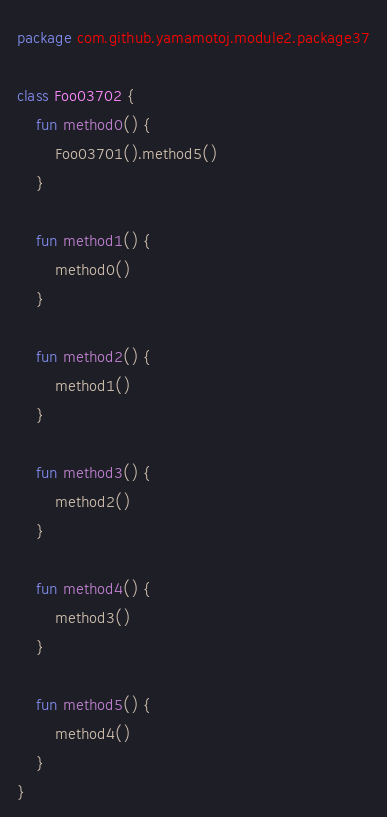Convert code to text. <code><loc_0><loc_0><loc_500><loc_500><_Kotlin_>package com.github.yamamotoj.module2.package37

class Foo03702 {
    fun method0() {
        Foo03701().method5()
    }

    fun method1() {
        method0()
    }

    fun method2() {
        method1()
    }

    fun method3() {
        method2()
    }

    fun method4() {
        method3()
    }

    fun method5() {
        method4()
    }
}
</code> 